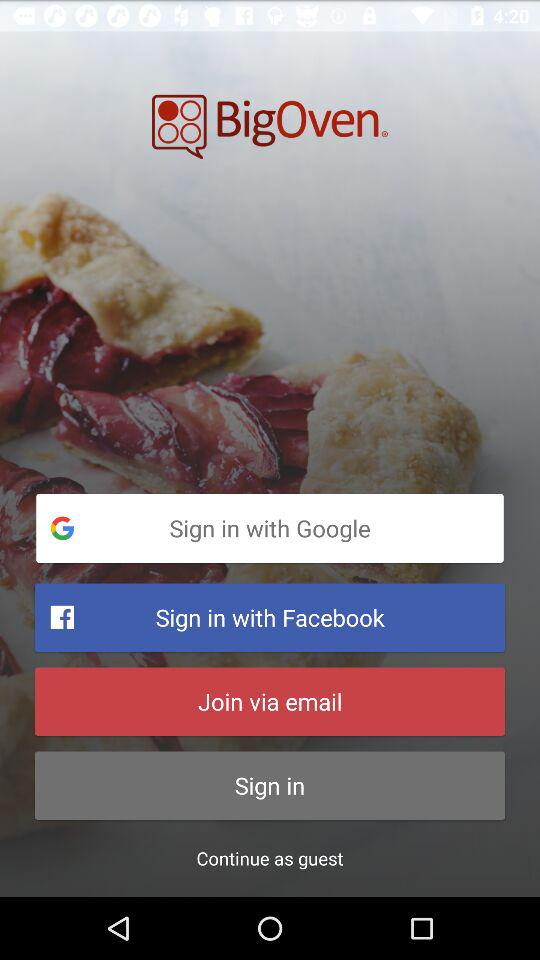What applications can be used to sign in to the profile? The applications that can be used to sign in to the profile are "Google" and "Facebook". 